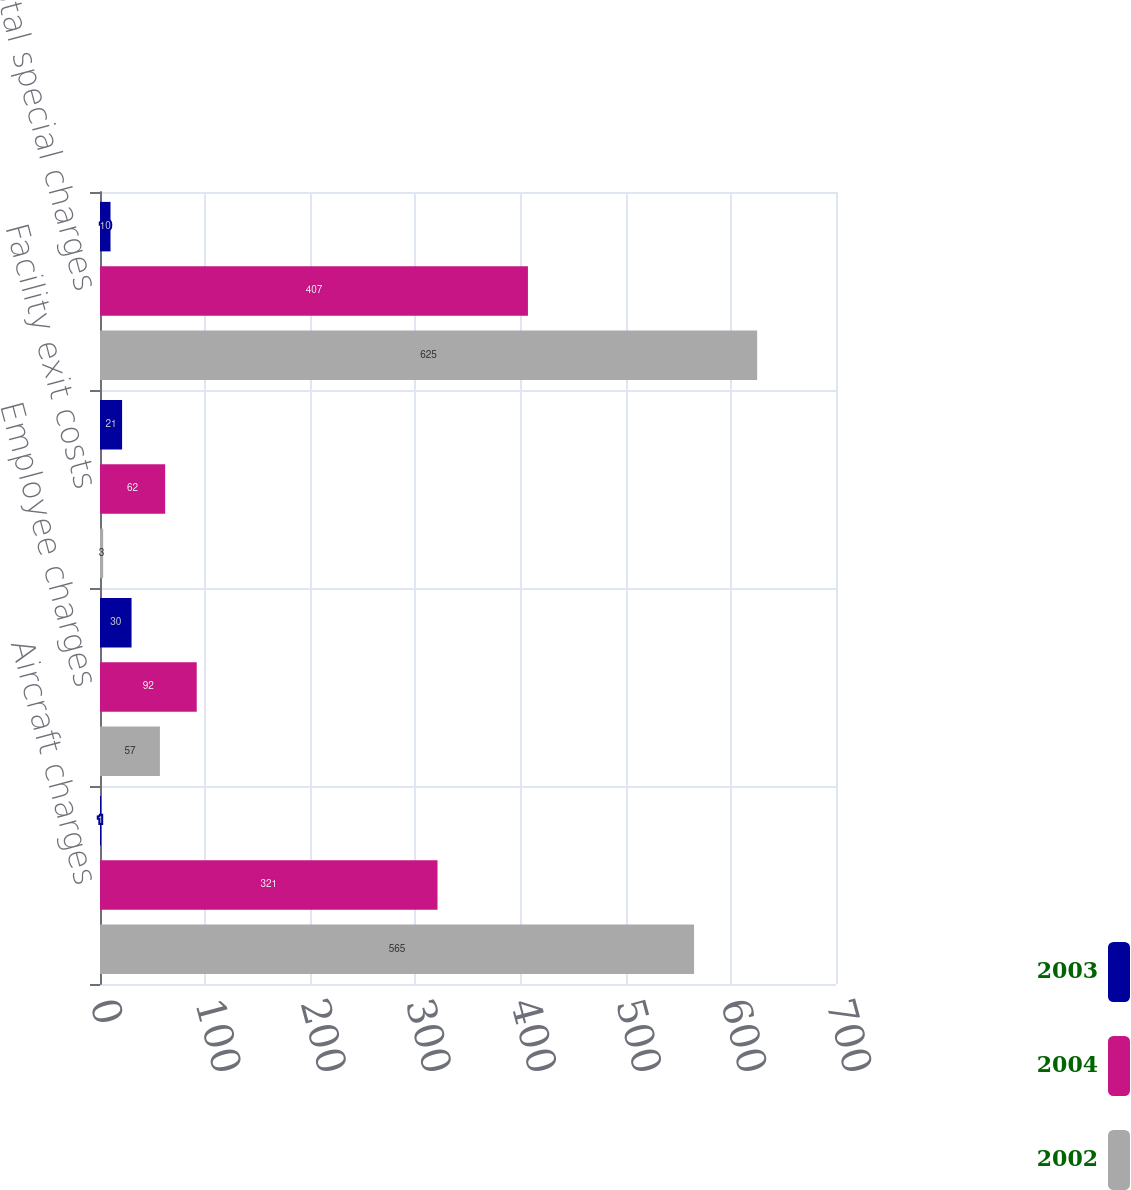<chart> <loc_0><loc_0><loc_500><loc_500><stacked_bar_chart><ecel><fcel>Aircraft charges<fcel>Employee charges<fcel>Facility exit costs<fcel>Total special charges<nl><fcel>2003<fcel>1<fcel>30<fcel>21<fcel>10<nl><fcel>2004<fcel>321<fcel>92<fcel>62<fcel>407<nl><fcel>2002<fcel>565<fcel>57<fcel>3<fcel>625<nl></chart> 